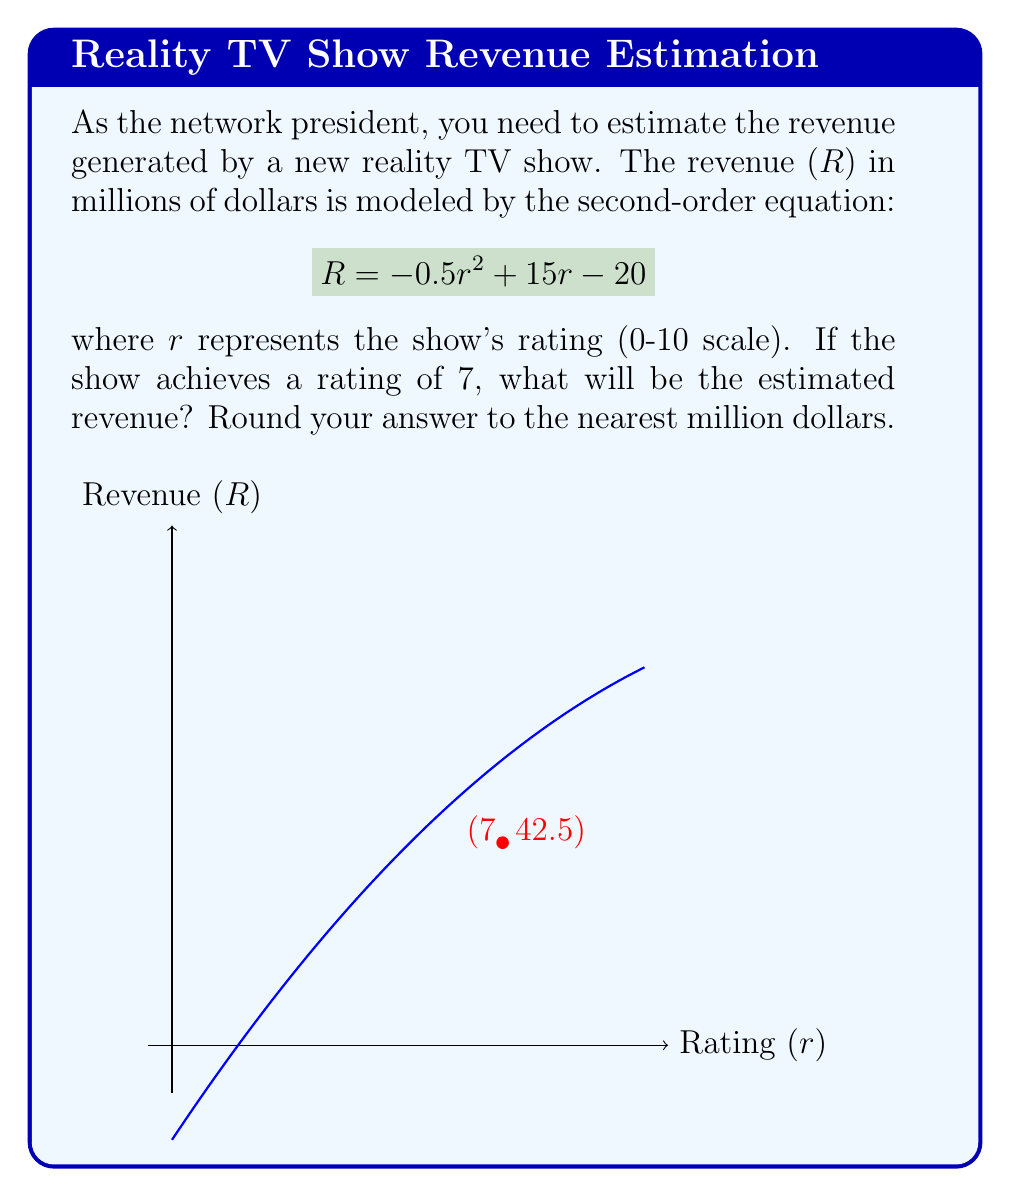What is the answer to this math problem? To solve this problem, we'll follow these steps:

1) We have the revenue equation:
   $$R = -0.5r^2 + 15r - 20$$

2) We need to find R when r = 7. Let's substitute r = 7 into the equation:
   $$R = -0.5(7)^2 + 15(7) - 20$$

3) Let's solve this step-by-step:
   $$R = -0.5(49) + 105 - 20$$
   $$R = -24.5 + 105 - 20$$
   $$R = 80.5 - 20$$
   $$R = 60.5$$

4) The question asks to round to the nearest million dollars:
   60.5 million rounds to 61 million dollars.

Thus, with a rating of 7, the estimated revenue for the show would be 61 million dollars.
Answer: $61 million 